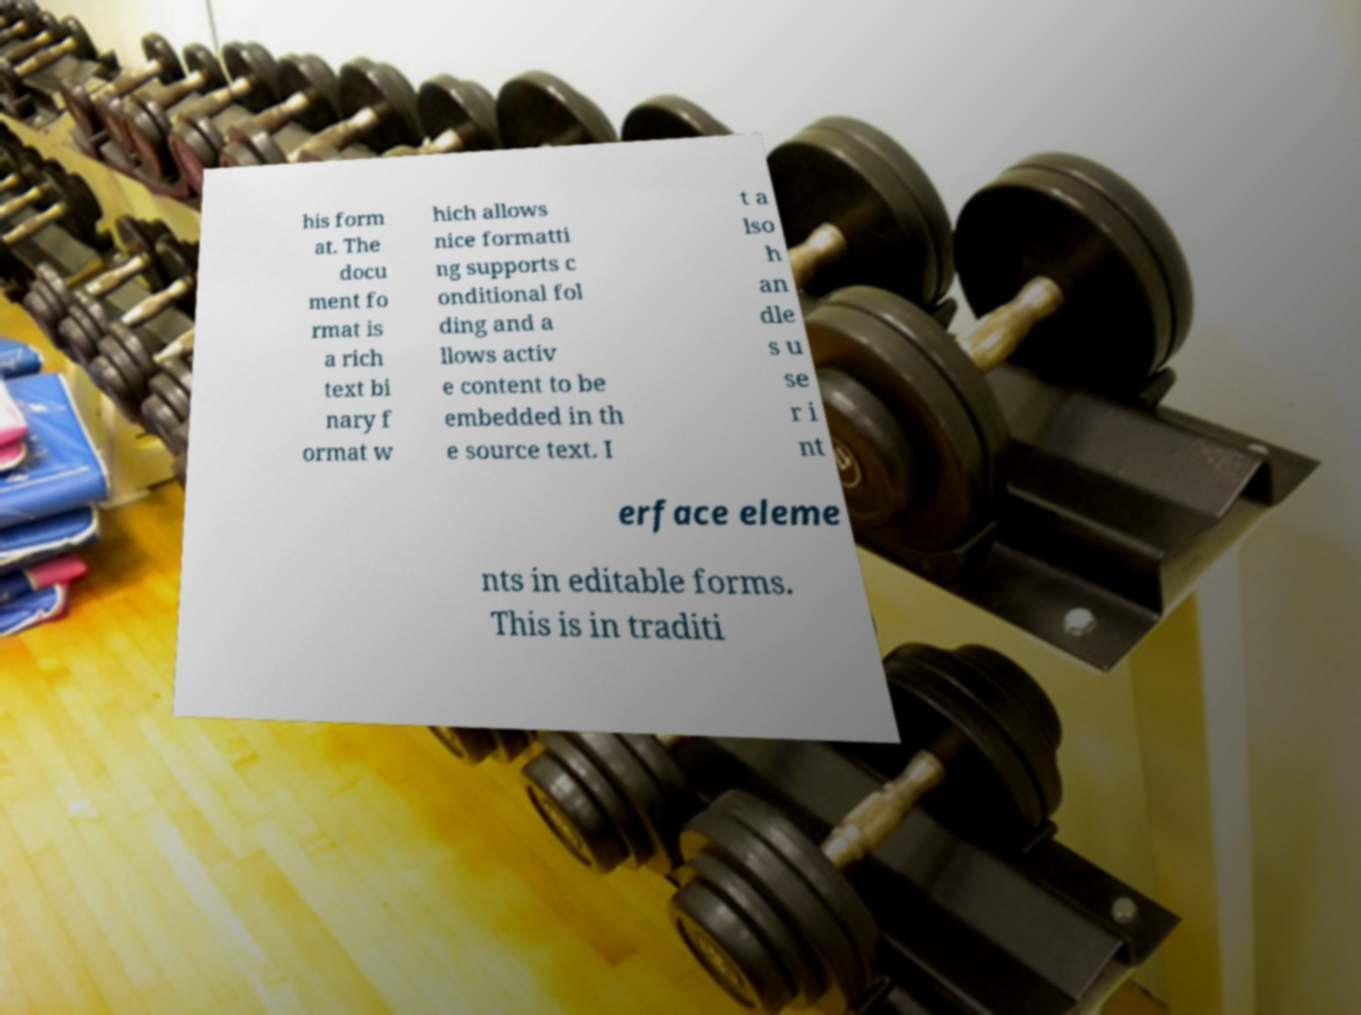Please read and relay the text visible in this image. What does it say? his form at. The docu ment fo rmat is a rich text bi nary f ormat w hich allows nice formatti ng supports c onditional fol ding and a llows activ e content to be embedded in th e source text. I t a lso h an dle s u se r i nt erface eleme nts in editable forms. This is in traditi 